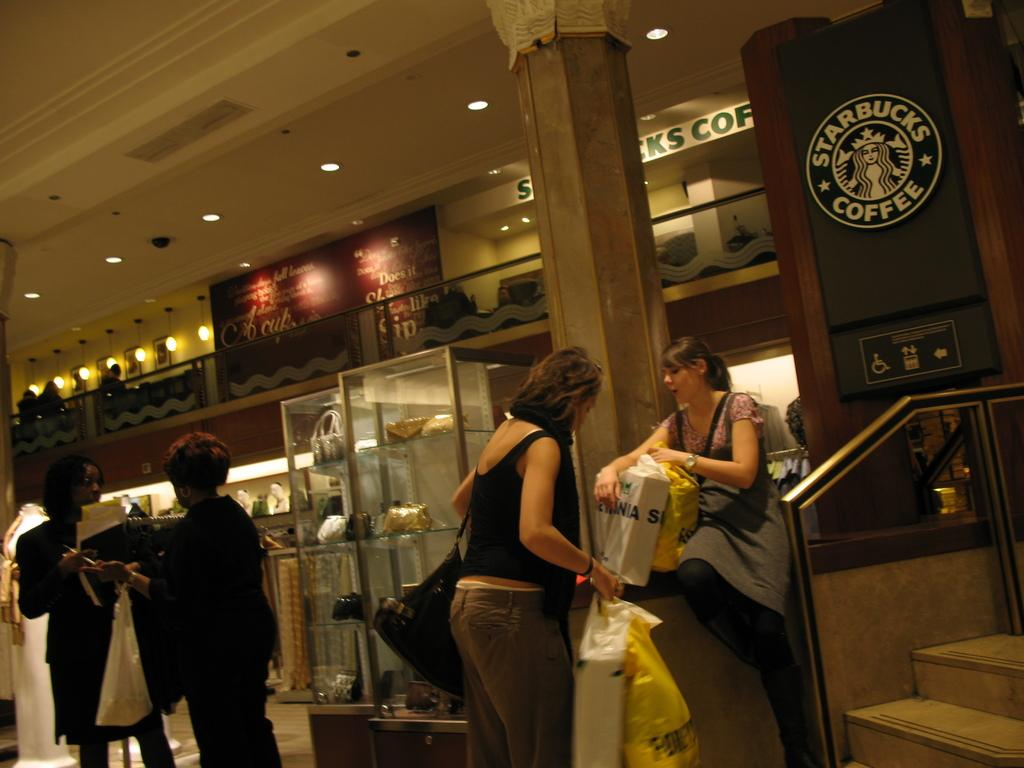What is the general arrangement of people in the image? There is a group of people standing in the image, and a woman sitting. What can be seen behind the people in the image? There are items visible behind the people in the image. Can you describe any architectural features in the image? Yes, there is a pillar in the image. What type of lighting is present in the image? Ceiling lights are present in the image. What type of pet can be seen interacting with the woman sitting in the image? There is no pet present in the image; only the group of people and the woman sitting are visible. What do the people in the image believe about the existence of ghosts? The image does not provide any information about the beliefs of the people in the image regarding ghosts. 